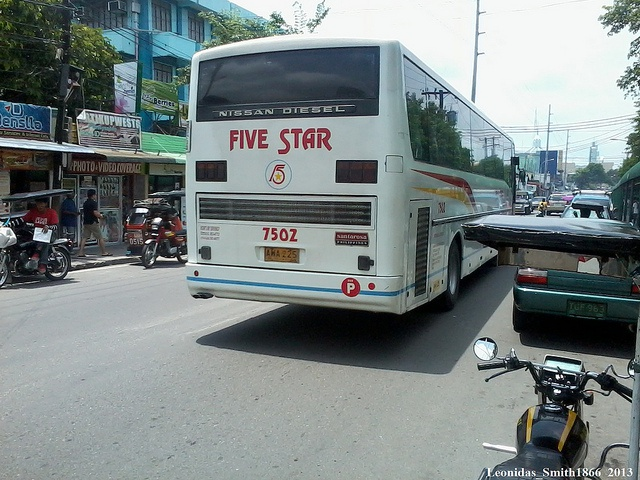Describe the objects in this image and their specific colors. I can see bus in lightgreen, darkgray, black, gray, and blue tones, motorcycle in lightgreen, black, darkgray, gray, and white tones, car in lightgreen, black, teal, gray, and darkblue tones, motorcycle in lightgreen, black, gray, darkgray, and purple tones, and motorcycle in lightgreen, black, gray, darkgray, and maroon tones in this image. 